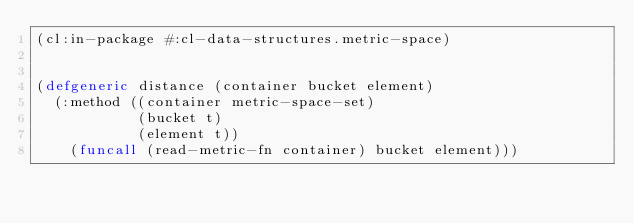<code> <loc_0><loc_0><loc_500><loc_500><_Lisp_>(cl:in-package #:cl-data-structures.metric-space)


(defgeneric distance (container bucket element)
  (:method ((container metric-space-set)
            (bucket t)
            (element t))
    (funcall (read-metric-fn container) bucket element)))
</code> 